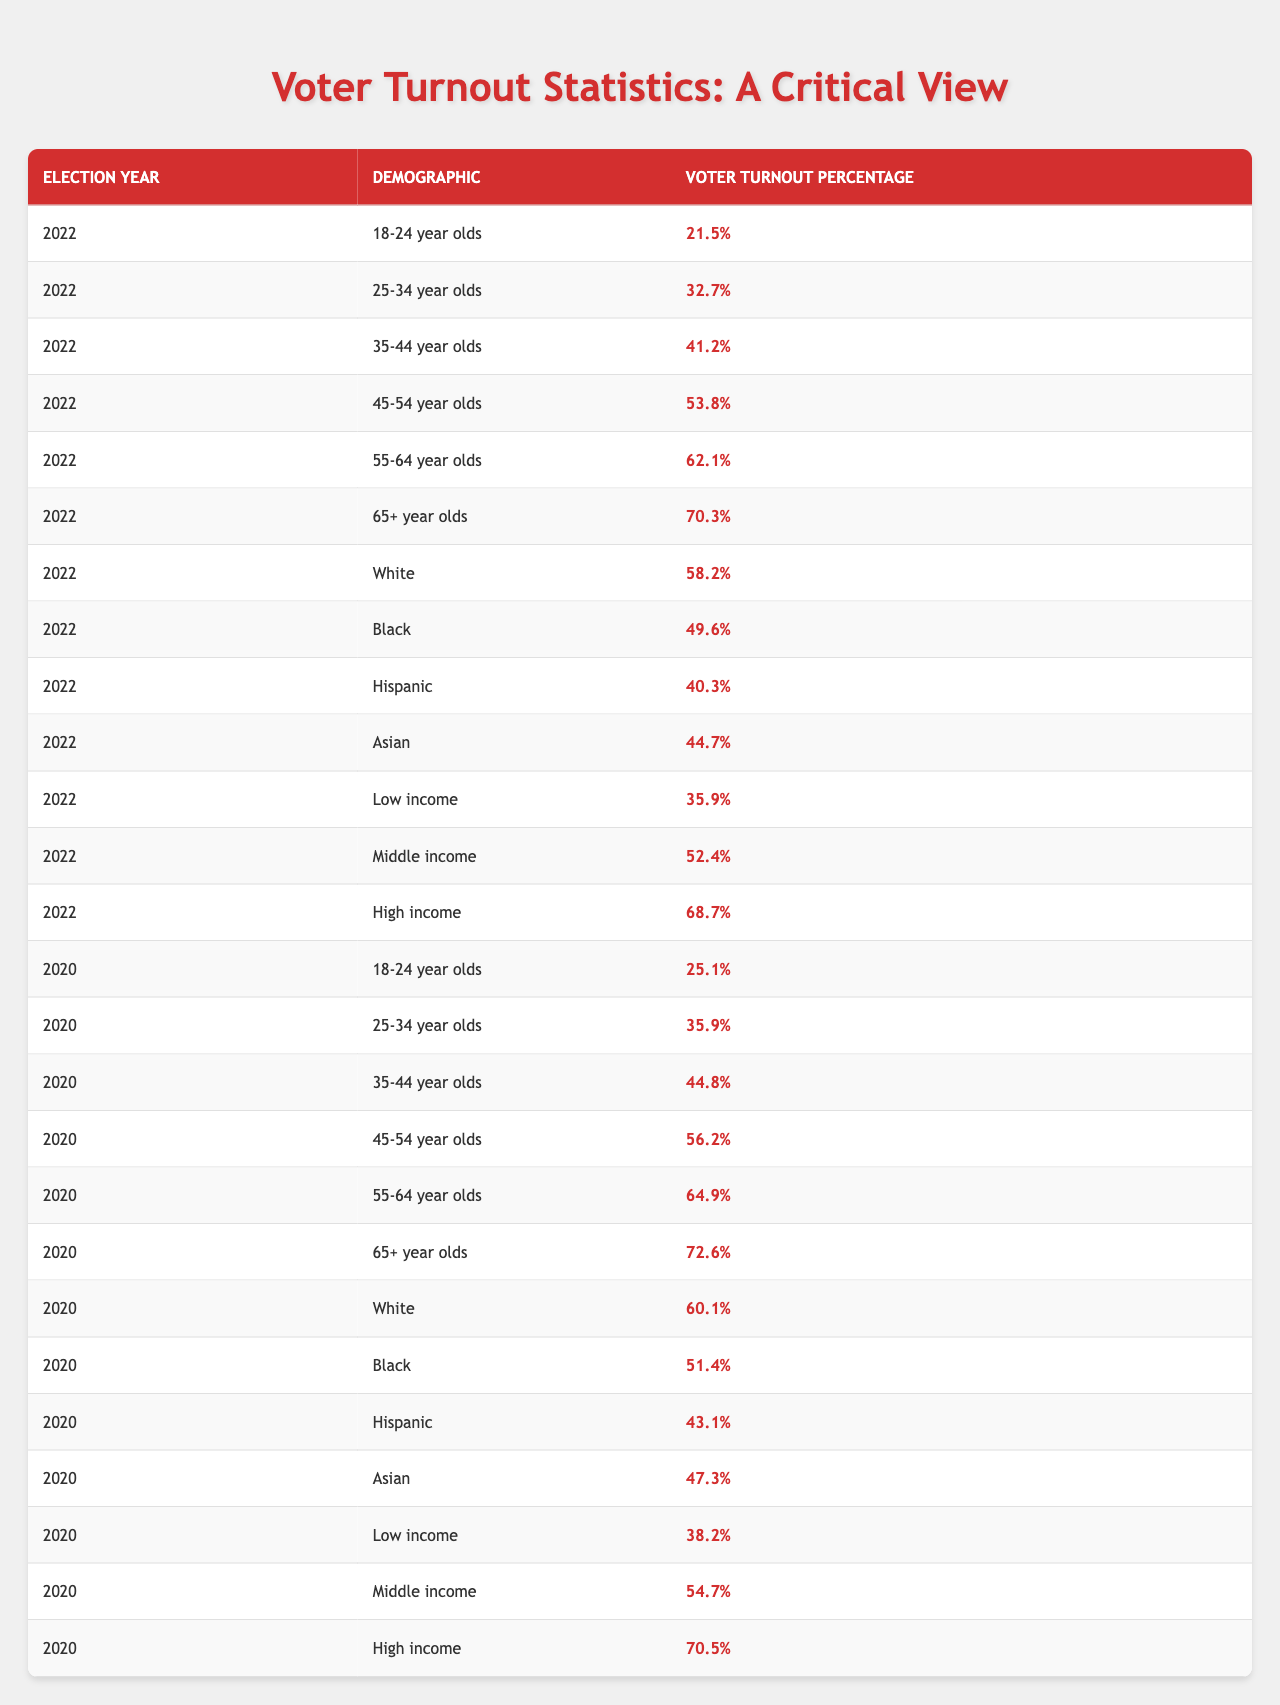What is the voter turnout percentage for 18-24 year olds in 2022? In the table, under the column for the year 2022 and the demographic of 18-24 year olds, the voter turnout percentage is given as 21.5%.
Answer: 21.5% Which demographic had the highest voter turnout in 2022? Checking the turnout percentages for 2022, the demographic with the highest percentage is the 65+ year olds, with a turnout of 70.3%.
Answer: 65+ year olds What is the difference in voter turnout between the 45-54 age group in 2020 and 2022? Looking at the percentages for the 45-54 year olds, in 2020 it is 56.2% and in 2022 it is 53.8%. Subtracting these gives 56.2% - 53.8% = 2.4%.
Answer: 2.4% Did the voter turnout for Black individuals increase from 2020 to 2022? The percentage for Black individuals in 2020 is 51.4%, and in 2022 it is 49.6%. Since 49.6% is lower than 51.4%, it indicates a decrease.
Answer: No What is the average voter turnout percentage for high-income individuals over the two election years? The turnout for high-income individuals is 70.5% in 2020 and 68.7% in 2022. Adding these percentages gives 139.2%, and dividing by 2 (the number of years) gives an average of 69.6%.
Answer: 69.6% Which demographic had the lowest voter turnout in 2022? Referring to the table, the demographic with the lowest turnout percentage in 2022 is the 18-24 year olds, with a turnout of 21.5%.
Answer: 18-24 year olds What was the increase in voter turnout for the 65+ age group from 2020 to 2022? The voter turnout percentage for the 65+ age group is 72.6% in 2020 and 70.3% in 2022. The decrease is calculated as 72.6% - 70.3% = 2.3%.
Answer: 2.3% decrease What is the median voter turnout for Hispanic individuals across the two years? The turnout percentages for Hispanic individuals are 43.1% in 2020 and 40.3% in 2022. The average of the two values is (43.1% + 40.3%) / 2 = 41.7%. Since there are only two numbers, the median is the average.
Answer: 41.7% Did voter turnout for low-income individuals improve from 2020 to 2022? In 2020, the turnout for low-income individuals was 38.2%, and in 2022 it is 35.9%. Since 35.9% is lower than 38.2%, it shows a decrease.
Answer: No What demographic had a higher voter turnout in 2022: Middle income or White individuals? In 2022, Middle income had a turnout of 52.4%, while White individuals had a turnout of 58.2%. Since 58.2% is greater than 52.4%, White individuals had a higher turnout.
Answer: White individuals 